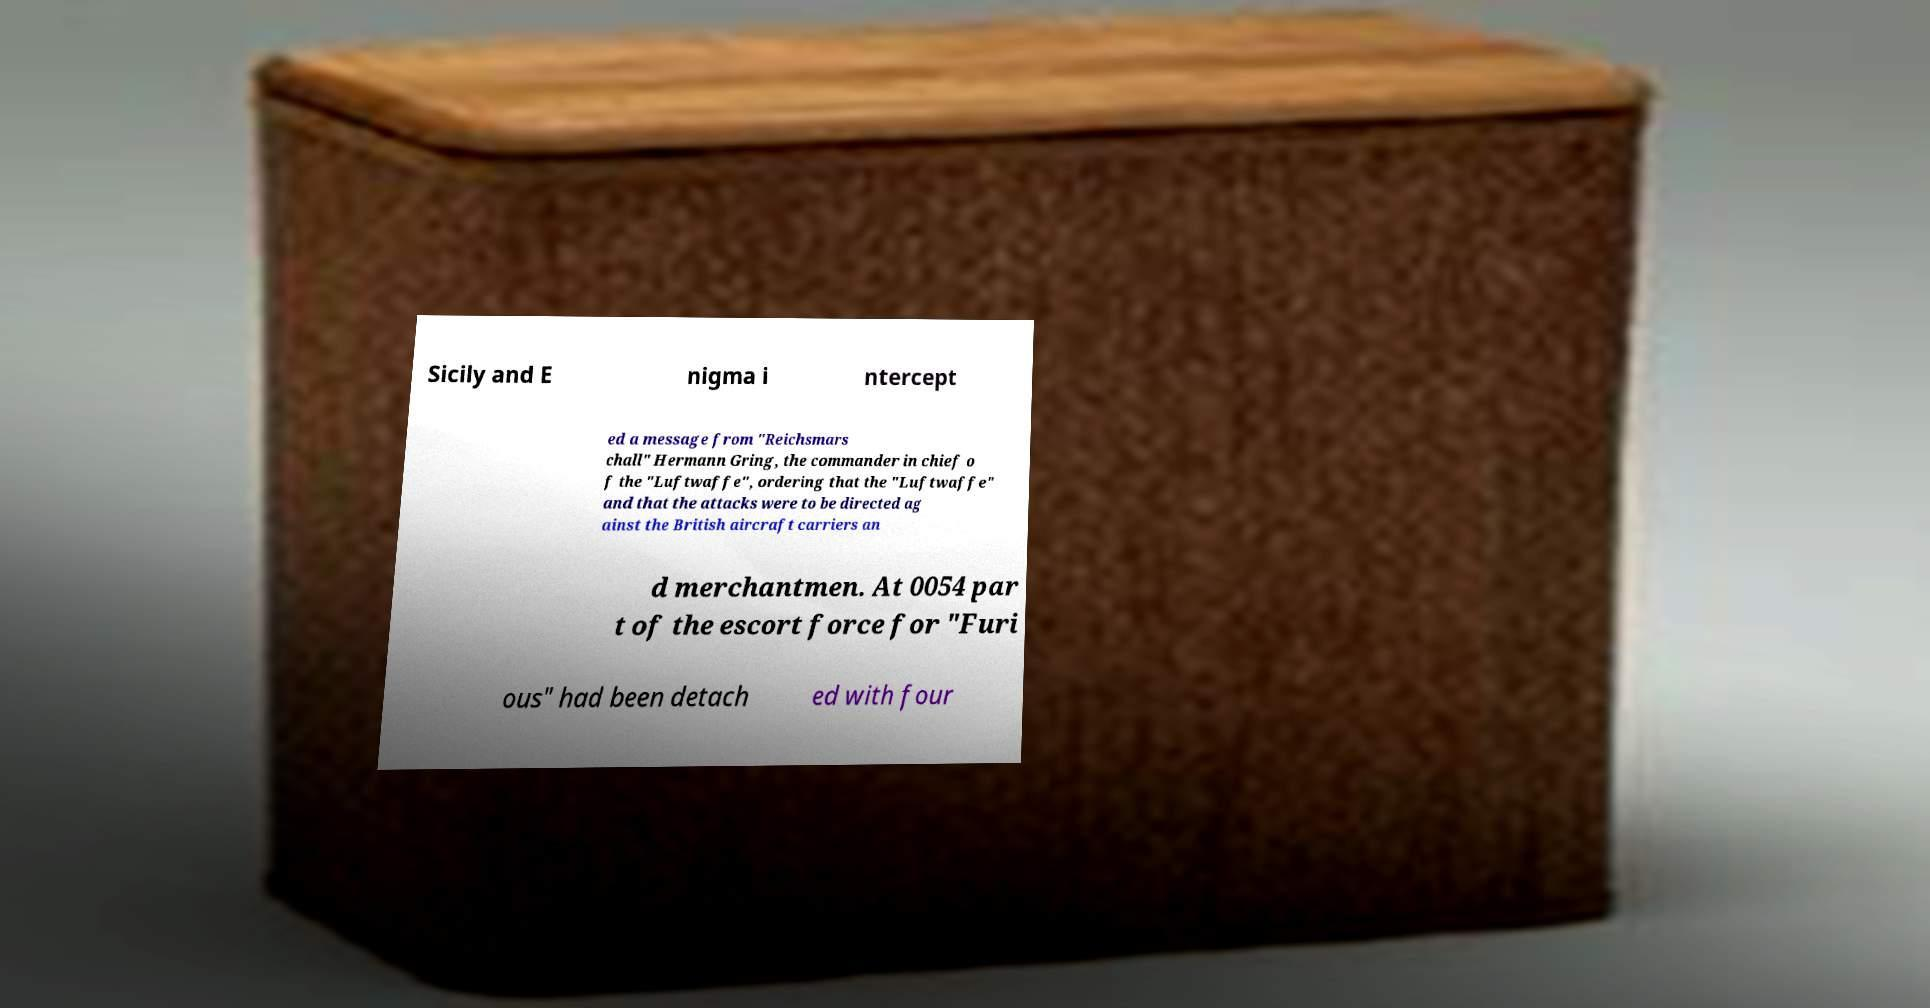I need the written content from this picture converted into text. Can you do that? Sicily and E nigma i ntercept ed a message from "Reichsmars chall" Hermann Gring, the commander in chief o f the "Luftwaffe", ordering that the "Luftwaffe" and that the attacks were to be directed ag ainst the British aircraft carriers an d merchantmen. At 0054 par t of the escort force for "Furi ous" had been detach ed with four 